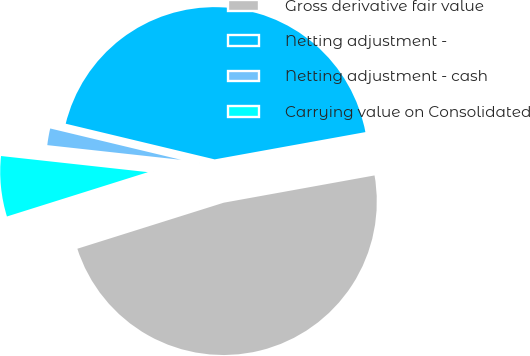Convert chart to OTSL. <chart><loc_0><loc_0><loc_500><loc_500><pie_chart><fcel>Gross derivative fair value<fcel>Netting adjustment -<fcel>Netting adjustment - cash<fcel>Carrying value on Consolidated<nl><fcel>48.0%<fcel>43.41%<fcel>2.0%<fcel>6.59%<nl></chart> 